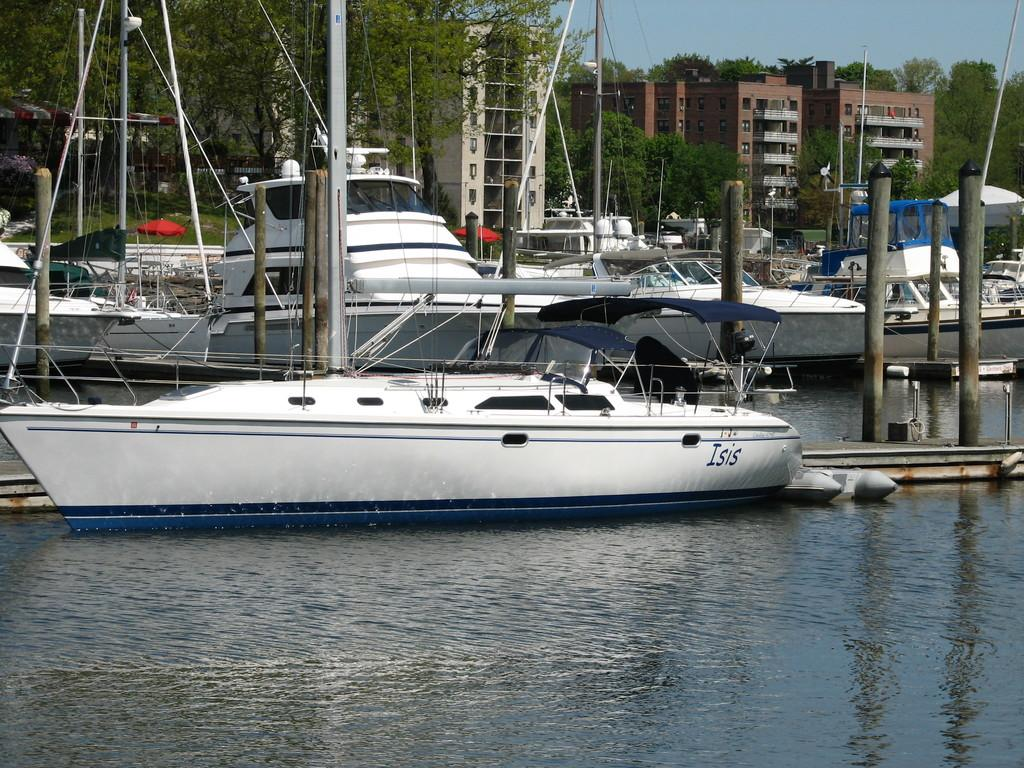What is present on the water in the image? There are boats on the water in the image. What can be seen in the background of the image? In the background, there are poles, trees, grass, buildings, and the sky. How many types of natural elements are visible in the background? There are three types of natural elements visible in the background: trees, grass, and the sky. What type of cloud can be seen flying in the image? There is no cloud visible in the image, let alone one that is flying. Is there a chain connecting the boats in the image? There is no chain connecting the boats in the image. 